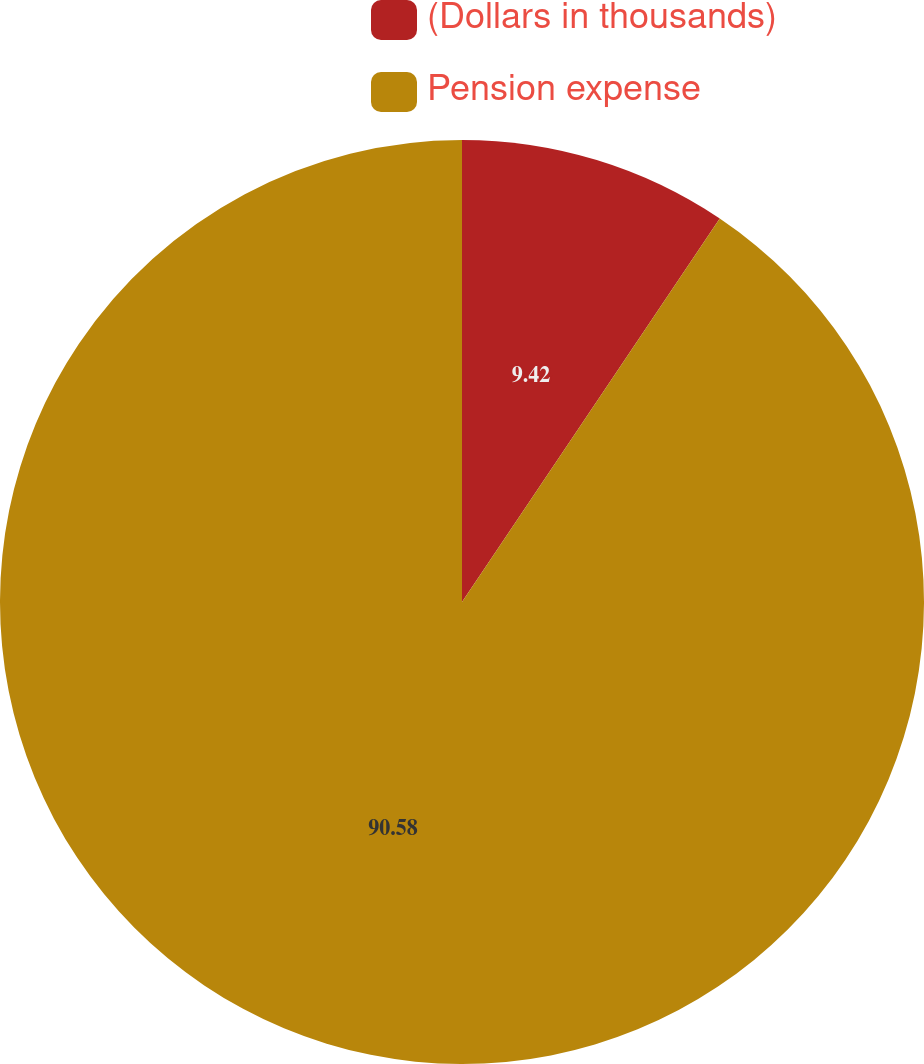<chart> <loc_0><loc_0><loc_500><loc_500><pie_chart><fcel>(Dollars in thousands)<fcel>Pension expense<nl><fcel>9.42%<fcel>90.58%<nl></chart> 